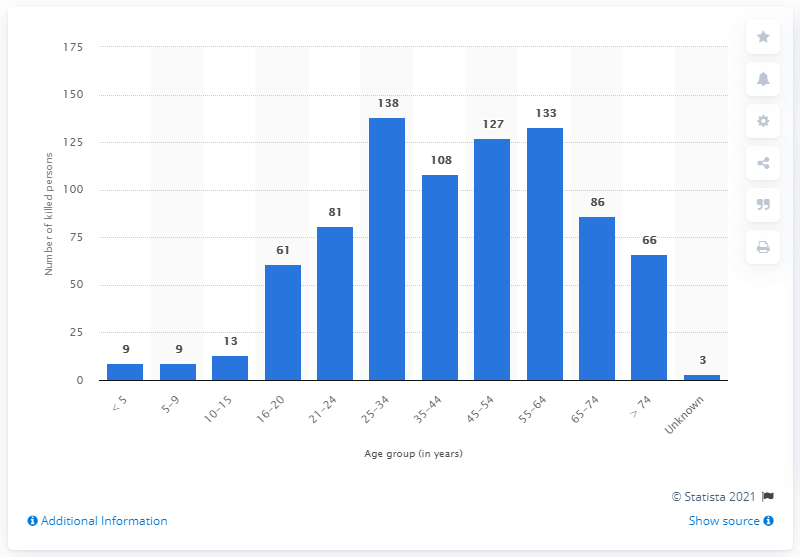Point out several critical features in this image. In 2016, a total of 138 individuals aged between 25 and 34 were killed on the roads of Kentucky. 